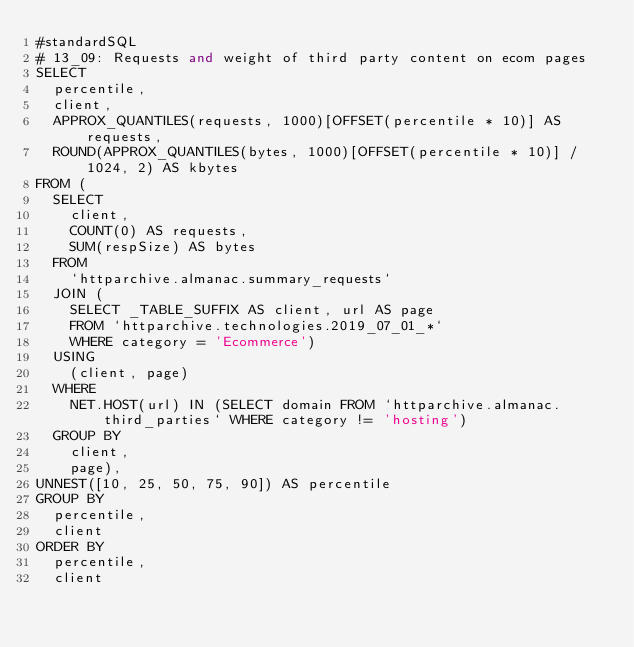<code> <loc_0><loc_0><loc_500><loc_500><_SQL_>#standardSQL
# 13_09: Requests and weight of third party content on ecom pages
SELECT
  percentile,
  client,
  APPROX_QUANTILES(requests, 1000)[OFFSET(percentile * 10)] AS requests,
  ROUND(APPROX_QUANTILES(bytes, 1000)[OFFSET(percentile * 10)] / 1024, 2) AS kbytes
FROM (
  SELECT
    client,
    COUNT(0) AS requests,
    SUM(respSize) AS bytes
  FROM
    `httparchive.almanac.summary_requests`
  JOIN (
    SELECT _TABLE_SUFFIX AS client, url AS page
    FROM `httparchive.technologies.2019_07_01_*`
    WHERE category = 'Ecommerce')
  USING
    (client, page)
  WHERE
    NET.HOST(url) IN (SELECT domain FROM `httparchive.almanac.third_parties` WHERE category != 'hosting')
  GROUP BY
    client,
    page),
UNNEST([10, 25, 50, 75, 90]) AS percentile
GROUP BY
  percentile,
  client
ORDER BY
  percentile,
  client
</code> 